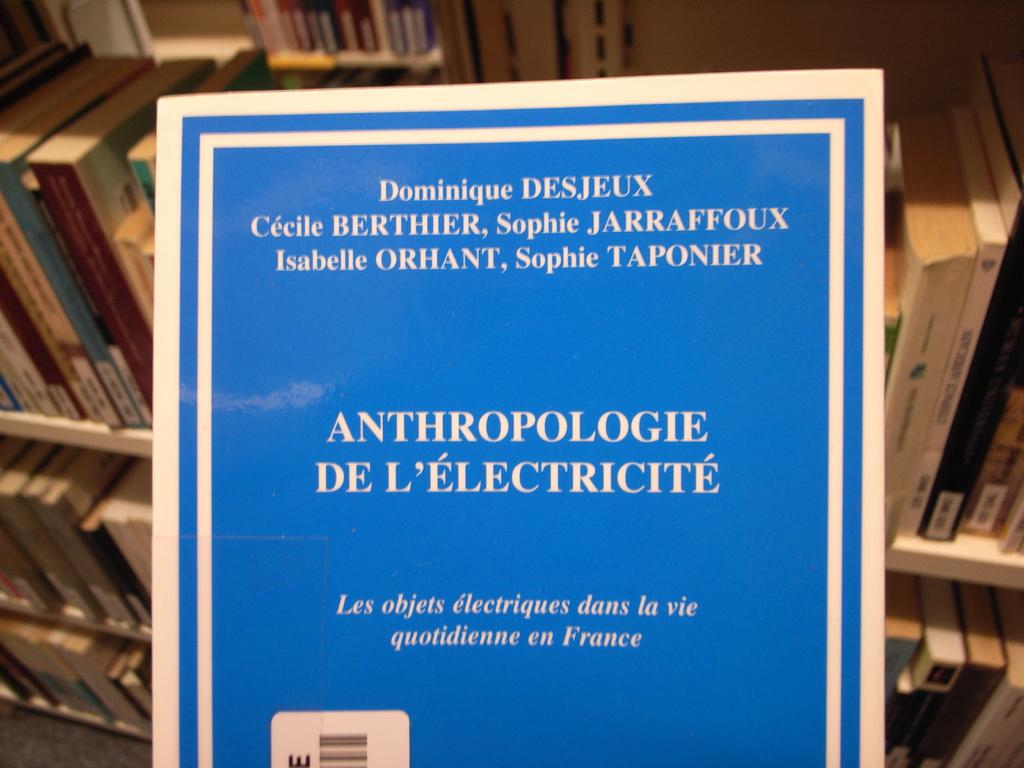What name is repeated twice?
Your answer should be compact. Sophie. Is the text in english?
Provide a short and direct response. No. 